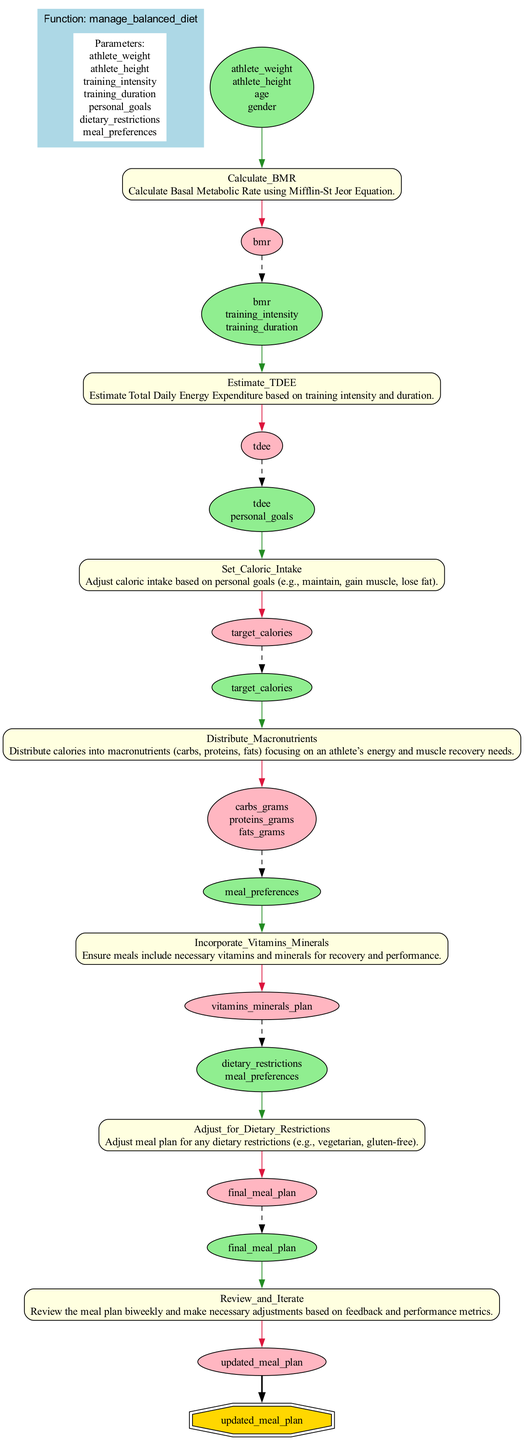What are the main parameters for the function? The diagram lists seven parameters: athlete weight, athlete height, training intensity, training duration, personal goals, dietary restrictions, and meal preferences. These are clearly indicated in the 'Parameters' box.
Answer: athlete weight, athlete height, training intensity, training duration, personal goals, dietary restrictions, meal preferences What is the output of the diagram? The final output node shows that the result of executing the function is the updated meal plan, which is derived from all previous steps in the flow.
Answer: updated meal plan How many steps are there in the function? By counting each of the steps listed in the diagram, I see there are seven distinct steps involved in the management of the balanced diet plan.
Answer: 7 Which step calculates the Basal Metabolic Rate? The 'Calculate_BMR' step is responsible for this computation, as indicated at the start of its description in the diagram.
Answer: Calculate_BMR What happens after estimating Total Daily Energy Expenditure? The output from the 'Estimate_TDEE' step feeds into the next step, 'Set_Caloric_Intake', which adjusts caloric intake based on personal goals. This flow is shown using the connection between these two steps in the diagram.
Answer: Set_Caloric_Intake What are the inputs for the 'Distribute_Macronutrients' step? Looking at the inputs listed for the 'Distribute_Macronutrients' step, it indicates 'target_calories' is the sole input for this step.
Answer: target_calories Which step adjusts the meal plan for dietary restrictions? The 'Adjust_for_Dietary_Restrictions' step is specifically designed for this purpose in the overall process. Its description clearly states that it incorporates any dietary restrictions into the meal plan.
Answer: Adjust_for_Dietary_Restrictions How does the diagram indicate the relationship between steps? The diagram indicates relationships using directed edges, showing the flow of information from one step to the next and including dashed lines for inputs connecting outputs of previous steps.
Answer: Directed edges What is the purpose of the 'Review_and_Iterate' step? This step is meant to evaluate the effectiveness of the meal plan on a biweekly basis and to make necessary adjustments. The purpose is defined clearly within its description in the diagram.
Answer: To review the meal plan biweekly 